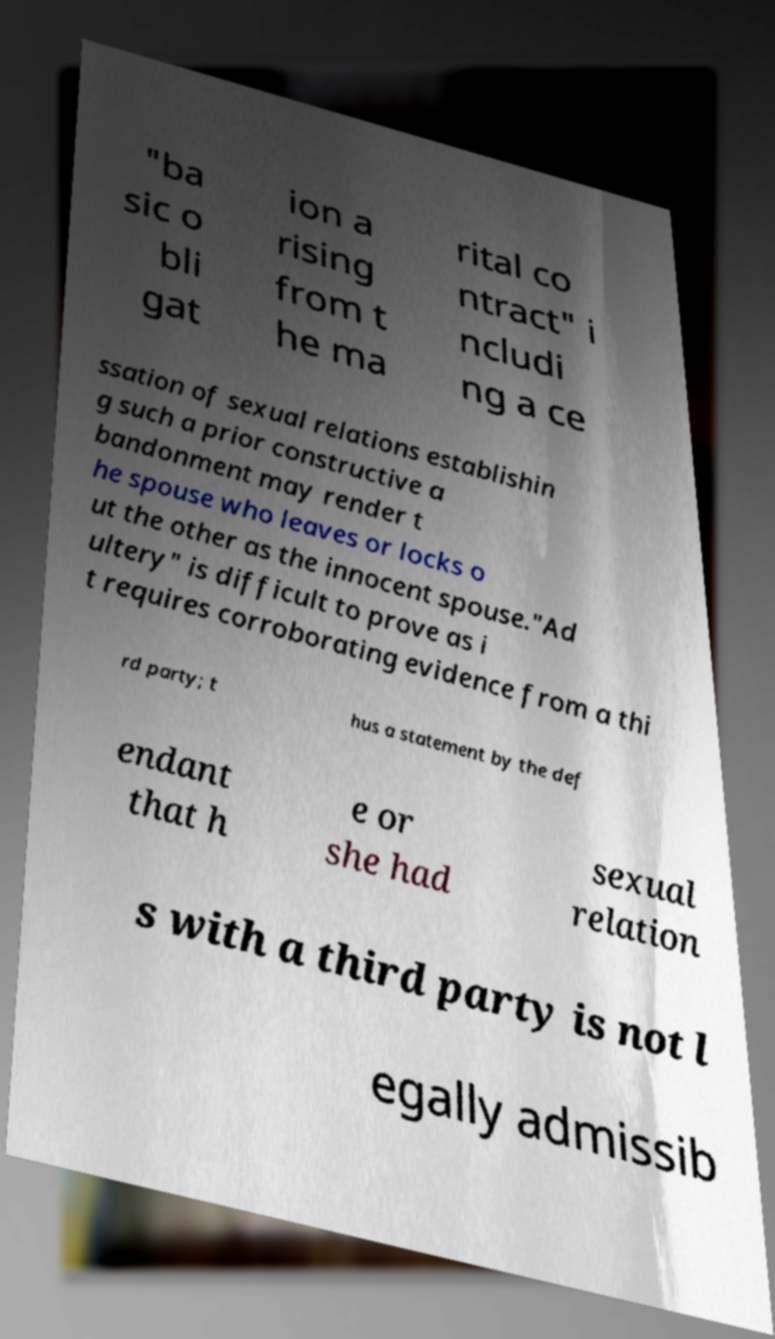Please read and relay the text visible in this image. What does it say? "ba sic o bli gat ion a rising from t he ma rital co ntract" i ncludi ng a ce ssation of sexual relations establishin g such a prior constructive a bandonment may render t he spouse who leaves or locks o ut the other as the innocent spouse."Ad ultery" is difficult to prove as i t requires corroborating evidence from a thi rd party; t hus a statement by the def endant that h e or she had sexual relation s with a third party is not l egally admissib 